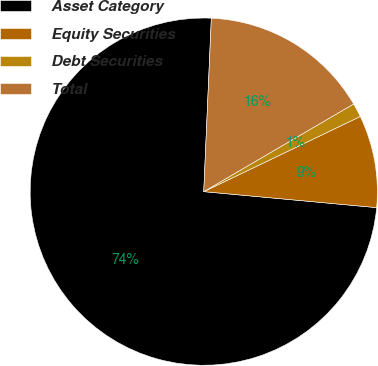Convert chart. <chart><loc_0><loc_0><loc_500><loc_500><pie_chart><fcel>Asset Category<fcel>Equity Securities<fcel>Debt Securities<fcel>Total<nl><fcel>74.23%<fcel>8.59%<fcel>1.3%<fcel>15.88%<nl></chart> 